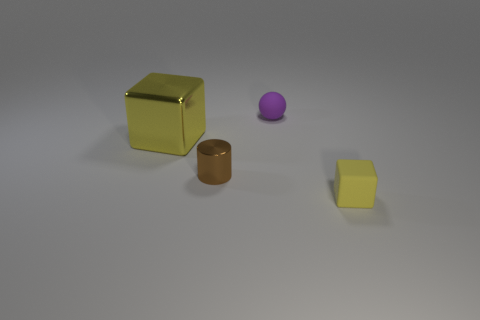Add 1 tiny yellow rubber objects. How many objects exist? 5 Subtract all cylinders. How many objects are left? 3 Subtract all brown blocks. How many gray cylinders are left? 0 Subtract all gray metallic spheres. Subtract all purple rubber things. How many objects are left? 3 Add 4 small purple objects. How many small purple objects are left? 5 Add 3 yellow matte things. How many yellow matte things exist? 4 Subtract 1 purple balls. How many objects are left? 3 Subtract 1 blocks. How many blocks are left? 1 Subtract all purple blocks. Subtract all yellow cylinders. How many blocks are left? 2 